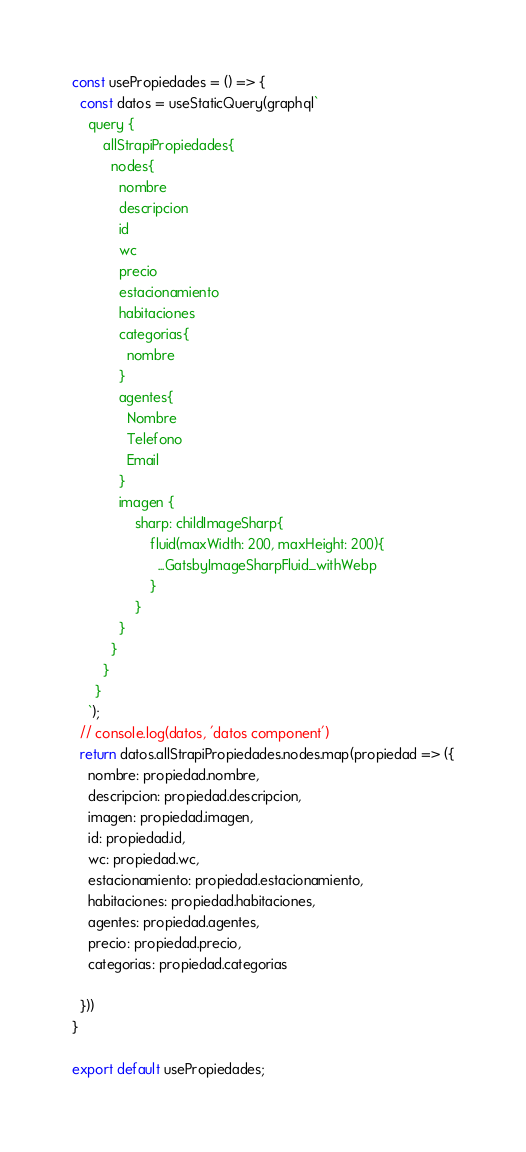Convert code to text. <code><loc_0><loc_0><loc_500><loc_500><_JavaScript_>
const usePropiedades = () => {
  const datos = useStaticQuery(graphql`
    query {
        allStrapiPropiedades{
          nodes{
            nombre
            descripcion
            id
            wc
            precio
            estacionamiento
            habitaciones
            categorias{
              nombre
            }
            agentes{
              Nombre
              Telefono
              Email
            }
            imagen {
                sharp: childImageSharp{
                    fluid(maxWidth: 200, maxHeight: 200){
                      ...GatsbyImageSharpFluid_withWebp
                    }
                }
            }
          }
        }
      }
    `);
  // console.log(datos, 'datos component')
  return datos.allStrapiPropiedades.nodes.map(propiedad => ({
    nombre: propiedad.nombre,
    descripcion: propiedad.descripcion,
    imagen: propiedad.imagen,
    id: propiedad.id,
    wc: propiedad.wc,
    estacionamiento: propiedad.estacionamiento,
    habitaciones: propiedad.habitaciones,
    agentes: propiedad.agentes,
    precio: propiedad.precio,
    categorias: propiedad.categorias

  }))
}

export default usePropiedades;</code> 